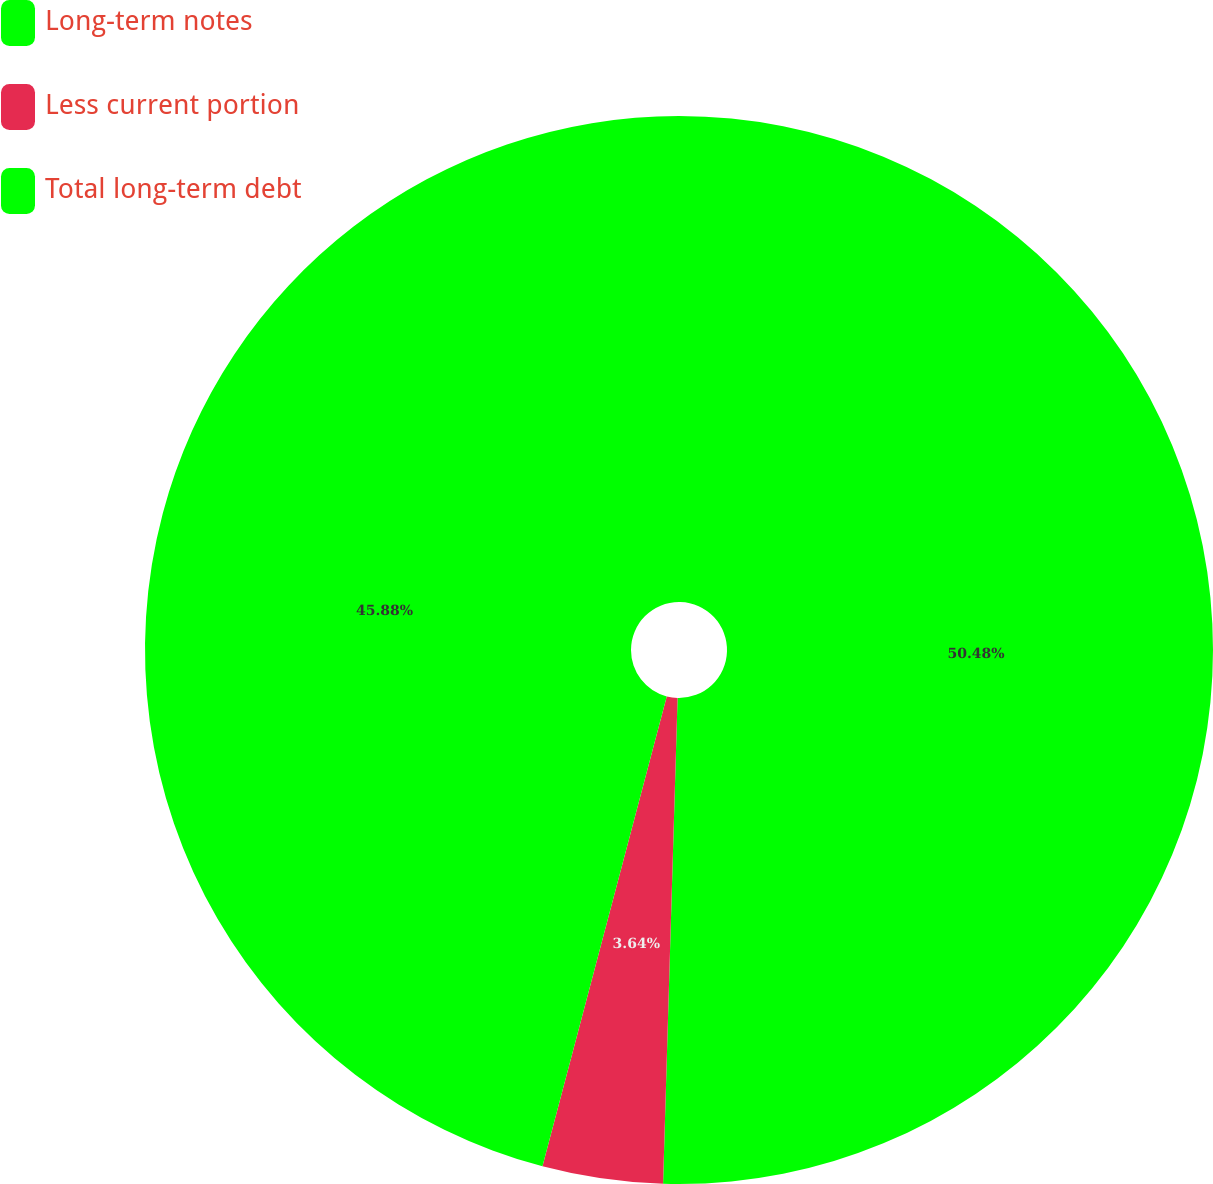<chart> <loc_0><loc_0><loc_500><loc_500><pie_chart><fcel>Long-term notes<fcel>Less current portion<fcel>Total long-term debt<nl><fcel>50.47%<fcel>3.64%<fcel>45.88%<nl></chart> 